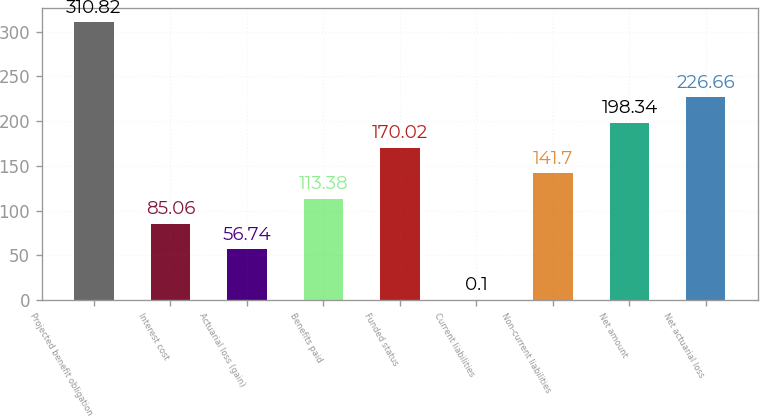<chart> <loc_0><loc_0><loc_500><loc_500><bar_chart><fcel>Projected benefit obligation<fcel>Interest cost<fcel>Actuarial loss (gain)<fcel>Benefits paid<fcel>Funded status<fcel>Current liabilities<fcel>Non-current liabilities<fcel>Net amount<fcel>Net actuarial loss<nl><fcel>310.82<fcel>85.06<fcel>56.74<fcel>113.38<fcel>170.02<fcel>0.1<fcel>141.7<fcel>198.34<fcel>226.66<nl></chart> 